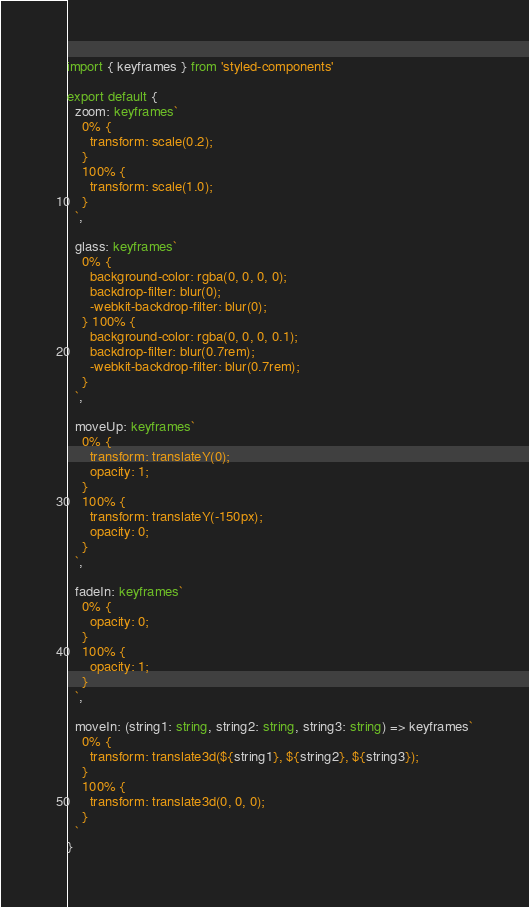Convert code to text. <code><loc_0><loc_0><loc_500><loc_500><_TypeScript_>import { keyframes } from 'styled-components'

export default {
  zoom: keyframes`
    0% {
      transform: scale(0.2);
    } 
    100% {
      transform: scale(1.0);
    }
  `,

  glass: keyframes`
    0% {
      background-color: rgba(0, 0, 0, 0);
      backdrop-filter: blur(0);
      -webkit-backdrop-filter: blur(0);
    } 100% {
      background-color: rgba(0, 0, 0, 0.1);
      backdrop-filter: blur(0.7rem);
      -webkit-backdrop-filter: blur(0.7rem);
    }
  `,

  moveUp: keyframes`
    0% {
      transform: translateY(0);
      opacity: 1;
    }
    100% {
      transform: translateY(-150px);
      opacity: 0;
    }
  `,

  fadeIn: keyframes`
    0% {
      opacity: 0;
    }
    100% {
      opacity: 1;
    }
  `,

  moveIn: (string1: string, string2: string, string3: string) => keyframes`
    0% {
      transform: translate3d(${string1}, ${string2}, ${string3});
    }
    100% {
      transform: translate3d(0, 0, 0);
    }
  `
}
</code> 